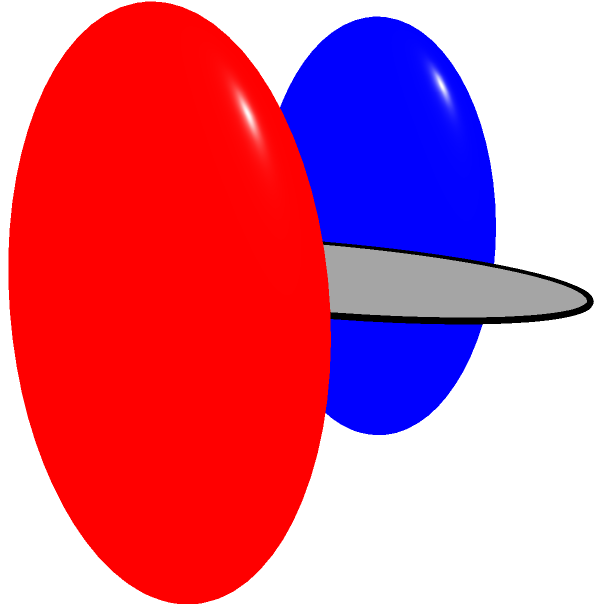As a retired bassist, you're reminiscing about your old audio setup. You notice that the surface formed by connecting your amplifier to your speaker with four curved cables (as shown in the image) resembles a familiar topological shape. What is the genus of this surface? To determine the genus of the surface, let's follow these steps:

1. Identify the shape: The surface formed by the cables connecting the amplifier and speaker is topologically equivalent to a torus (donut shape).

2. Recall the definition of genus: The genus of a surface is the maximum number of simple closed curves that can be drawn on the surface without separating it into disjoint regions.

3. Analyze the torus:
   a) We can draw one closed curve around the "hole" of the torus (longitudinally).
   b) We can draw another closed curve around the "tube" of the torus (latitudinally).
   c) These two curves do not separate the surface into disjoint regions.
   d) Adding any additional non-intersecting closed curve would separate the surface.

4. Count the number of curves: We were able to draw two non-separating curves.

5. Conclude: The genus of a torus is equal to the number of non-separating curves we could draw, which is 2.

Therefore, the genus of the surface formed by the audio cable configuration is 1.
Answer: 1 